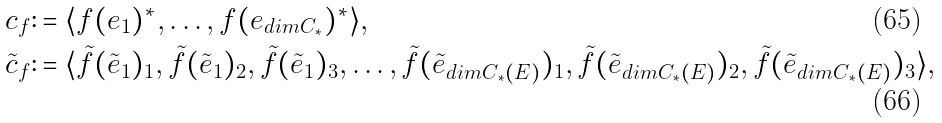Convert formula to latex. <formula><loc_0><loc_0><loc_500><loc_500>c _ { f } & \colon = \langle f ( e _ { 1 } ) ^ { * } , \dots , f ( e _ { d i m C _ { * } } ) ^ { * } \rangle , \\ \tilde { c } _ { f } & \colon = \langle \tilde { f } ( \tilde { e } _ { 1 } ) _ { 1 } , \tilde { f } ( \tilde { e } _ { 1 } ) _ { 2 } , \tilde { f } ( \tilde { e } _ { 1 } ) _ { 3 } , \dots , \tilde { f } ( \tilde { e } _ { d i m C _ { * } ( E ) } ) _ { 1 } , \tilde { f } ( \tilde { e } _ { d i m C _ { * } ( E ) } ) _ { 2 } , \tilde { f } ( \tilde { e } _ { d i m C _ { * } ( E ) } ) _ { 3 } \rangle ,</formula> 